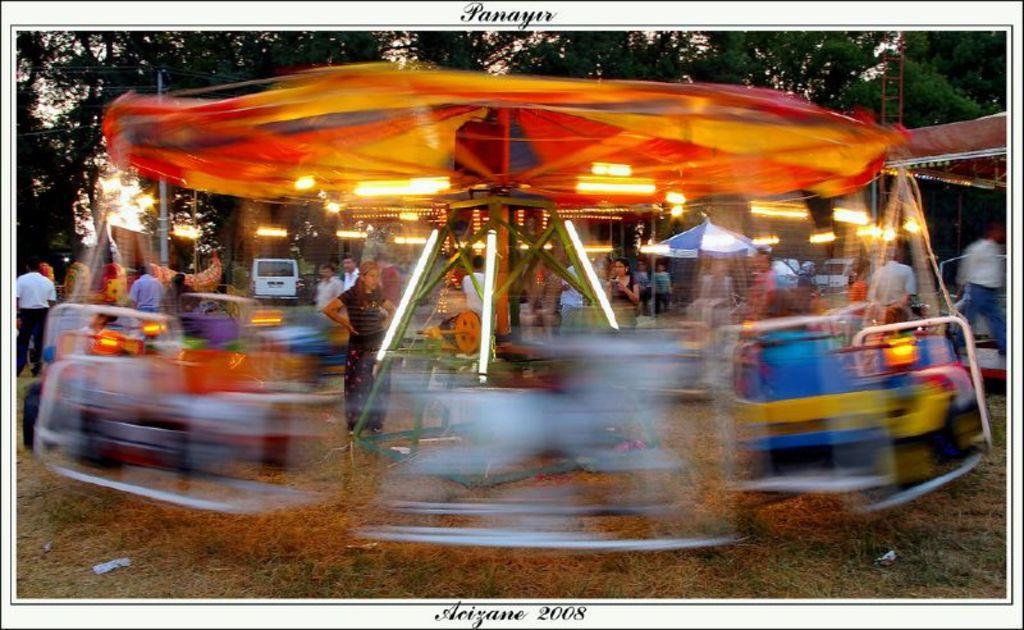How would you summarize this image in a sentence or two? In the picture I can see people standing on the ground. I can also see lights and some other objects on the ground. In the background I can see trees. I can also see something written on the image. 